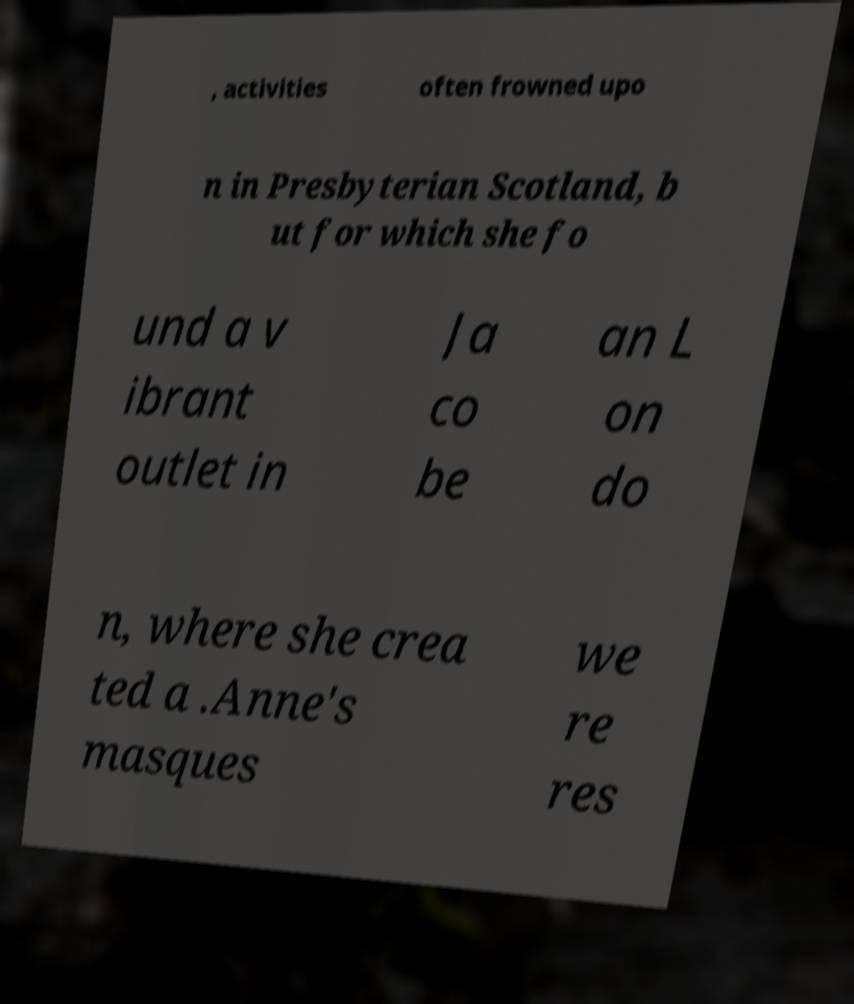Please read and relay the text visible in this image. What does it say? , activities often frowned upo n in Presbyterian Scotland, b ut for which she fo und a v ibrant outlet in Ja co be an L on do n, where she crea ted a .Anne's masques we re res 